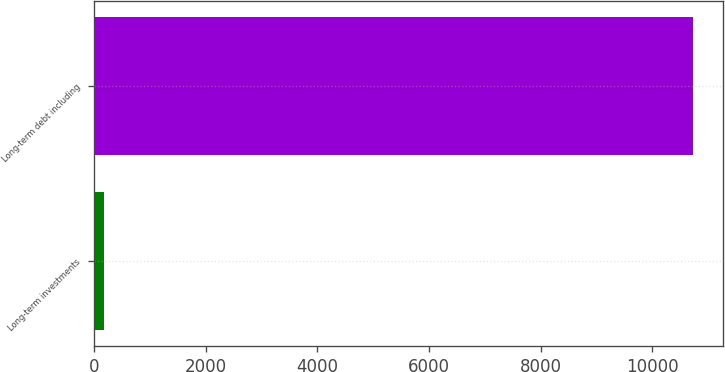Convert chart. <chart><loc_0><loc_0><loc_500><loc_500><bar_chart><fcel>Long-term investments<fcel>Long-term debt including<nl><fcel>174<fcel>10734<nl></chart> 